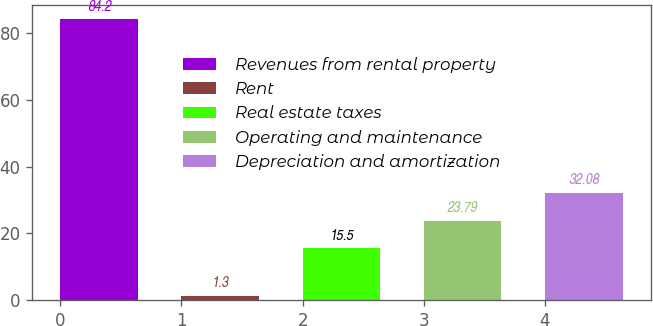Convert chart. <chart><loc_0><loc_0><loc_500><loc_500><bar_chart><fcel>Revenues from rental property<fcel>Rent<fcel>Real estate taxes<fcel>Operating and maintenance<fcel>Depreciation and amortization<nl><fcel>84.2<fcel>1.3<fcel>15.5<fcel>23.79<fcel>32.08<nl></chart> 